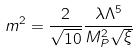Convert formula to latex. <formula><loc_0><loc_0><loc_500><loc_500>m ^ { 2 } = \frac { 2 } { \sqrt { 1 0 } } \frac { \lambda \Lambda ^ { 5 } } { M _ { P } ^ { 2 } \sqrt { \xi } }</formula> 